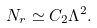<formula> <loc_0><loc_0><loc_500><loc_500>N _ { r } \simeq C _ { 2 } \Lambda ^ { 2 } .</formula> 